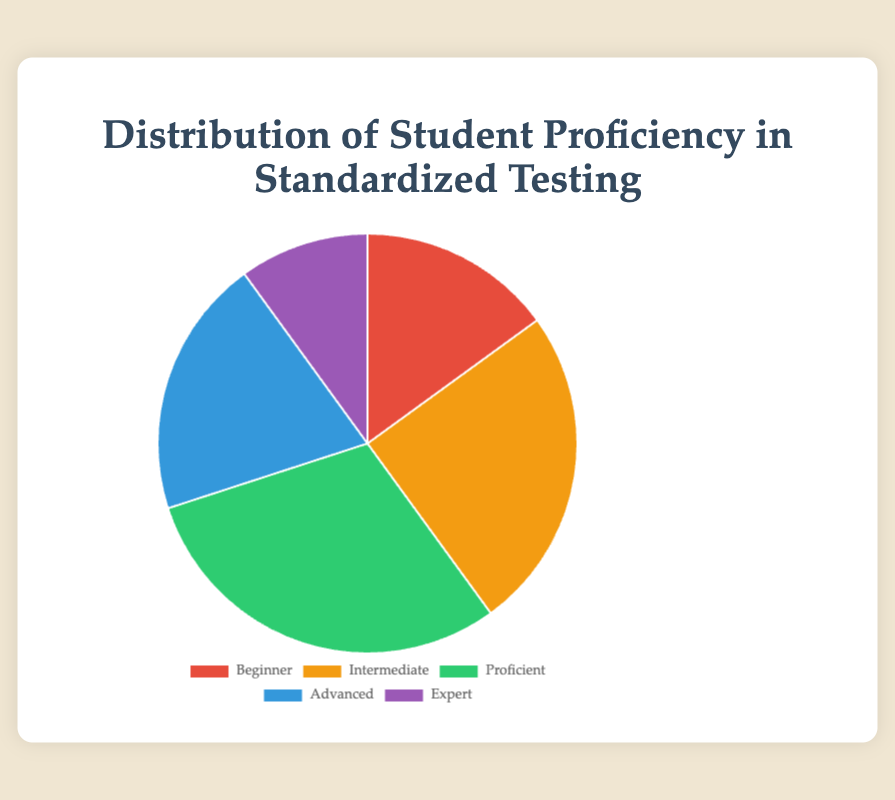What percentage of students are either at the proficient or advanced levels? To find the combined percentage of students at the proficient and advanced levels, add their respective percentages: Proficient (30%) + Advanced (20%) = 50%.
Answer: 50% Which proficiency level has the lowest percentage of students? By observing the pie chart, we see that the Expert level has the lowest percentage of students at 10%.
Answer: Expert How much larger is the proficient group compared to the beginner group? The proficient group is 30% while the beginner group is 15%. To find how much larger the proficient group is, subtract the percentage of the beginner group from that of the proficient group: 30% - 15% = 15%.
Answer: 15% What is the total percentage of students who are above the intermediate level? Students above the intermediate level include those at the proficient, advanced, and expert levels. Add their percentages: Proficient (30%) + Advanced (20%) + Expert (10%) = 60%.
Answer: 60% Which proficiency level is depicted in green on the pie chart? The pie chart uses distinct colors for each proficiency level. By matching the color green to its label, we see that the Proficient level is depicted in green.
Answer: Proficient How many more students are at the intermediate level compared to the expert level as a percentage? To find the difference in percentages between the intermediate and expert levels, subtract the expert percentage from the intermediate percentage: Intermediate (25%) - Expert (10%) = 15%.
Answer: 15% What two proficiency levels combined make up half of the student population? To find two levels that make up 50% combined, we look for a pair whose percentages sum to 50%. Proficient (30%) + Advanced (20%) = 50%.
Answer: Proficient and Advanced Is the percentage of students at the beginner level greater than the percentage of students at the expert level? By comparing the percentages of the beginner level (15%) and the expert level (10%), we see that the percentage of students at the beginner level is greater.
Answer: Yes Which proficiency level represents exactly a quarter of the student population? The pie chart indicates that 25% of students are at the Intermediate level, which represents a quarter of the population.
Answer: Intermediate 